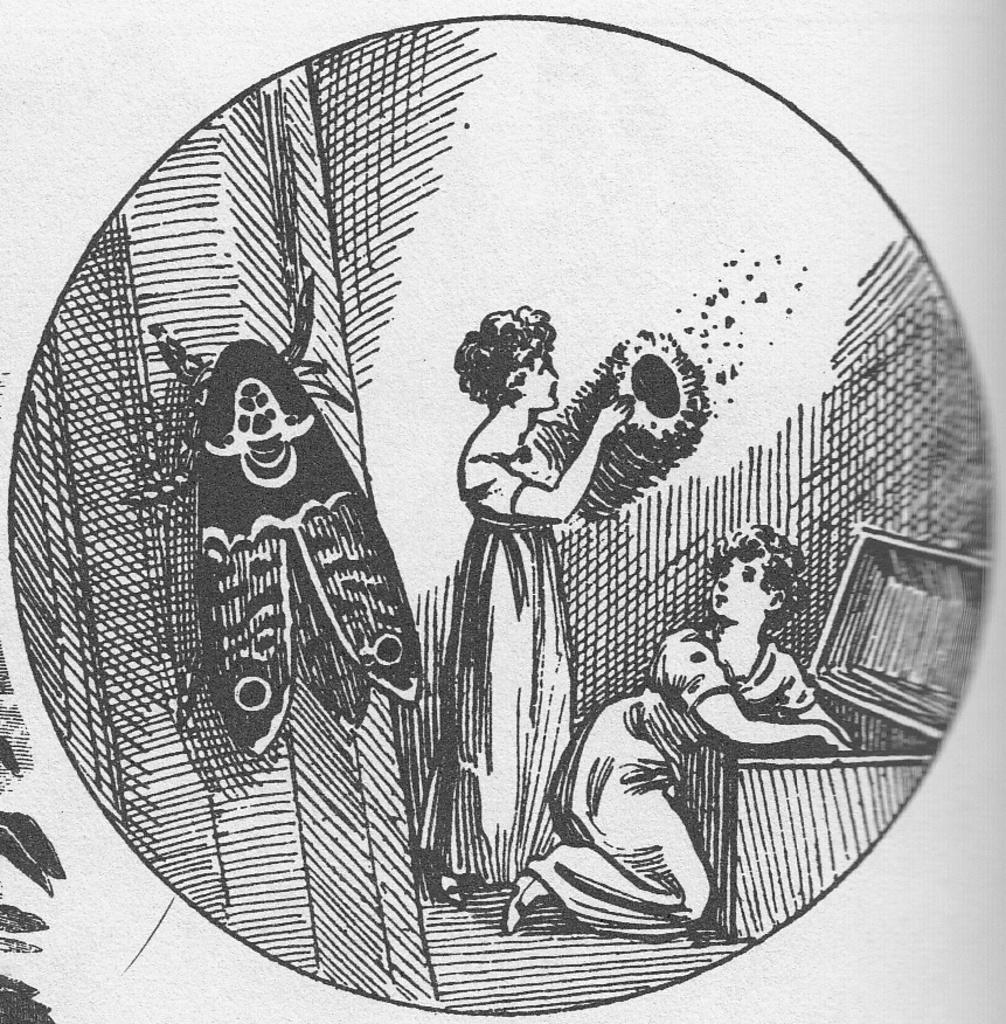How many women are in the image? There are two women in the image. What are the women doing in the image? The women are standing with a huge box in front of them. Is there anything else present in the image besides the women and the box? Yes, there is a fly on the wall in the image. On which side of the image is the fly located? The fly is on the left side of the image. What day of the week is depicted in the image? The image does not depict a specific day of the week. Can you see any stars in the image? There are no stars visible in the image. Is the image based on a fictional story? The image does not appear to be based on a fictional story. 